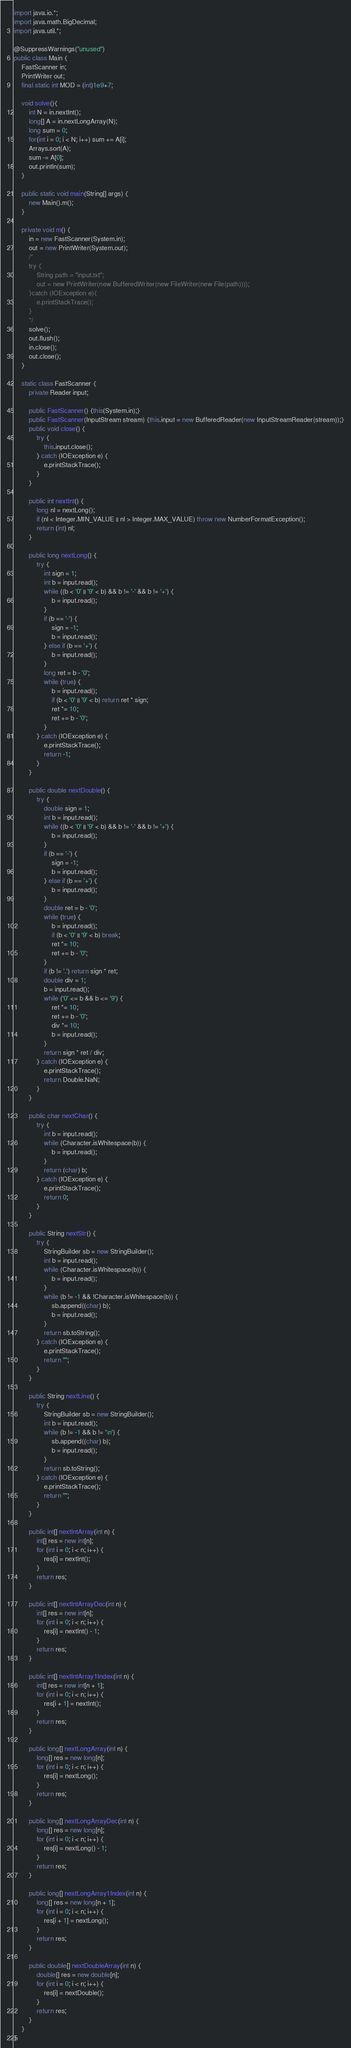<code> <loc_0><loc_0><loc_500><loc_500><_Java_>import java.io.*;
import java.math.BigDecimal;
import java.util.*;

@SuppressWarnings("unused")
public class Main {
    FastScanner in;
    PrintWriter out;
    final static int MOD = (int)1e9+7;
    
    void solve(){
        int N = in.nextInt();
        long[] A = in.nextLongArray(N);
        long sum = 0;
        for(int i = 0; i < N; i++) sum += A[i];
        Arrays.sort(A);
        sum -= A[0];
        out.println(sum);
    }
    
    public static void main(String[] args) {
        new Main().m();
    }
    
    private void m() {
        in = new FastScanner(System.in);
        out = new PrintWriter(System.out);
        /*
        try {
            String path = "input.txt";
            out = new PrintWriter(new BufferedWriter(new FileWriter(new File(path))));
        }catch (IOException e){
            e.printStackTrace();
        }
        */
        solve();
        out.flush();
        in.close();
        out.close();
    }
    
    static class FastScanner {
        private Reader input;
        
        public FastScanner() {this(System.in);}
        public FastScanner(InputStream stream) {this.input = new BufferedReader(new InputStreamReader(stream));}
        public void close() {
            try {
                this.input.close();
            } catch (IOException e) {
                e.printStackTrace();
            }
        }
        
        public int nextInt() {
            long nl = nextLong();
            if (nl < Integer.MIN_VALUE || nl > Integer.MAX_VALUE) throw new NumberFormatException();
            return (int) nl;
        }
        
        public long nextLong() {
            try {
                int sign = 1;
                int b = input.read();
                while ((b < '0' || '9' < b) && b != '-' && b != '+') {
                    b = input.read();
                }
                if (b == '-') {
                    sign = -1;
                    b = input.read();
                } else if (b == '+') {
                    b = input.read();
                }
                long ret = b - '0';
                while (true) {
                    b = input.read();
                    if (b < '0' || '9' < b) return ret * sign;
                    ret *= 10;
                    ret += b - '0';
                }
            } catch (IOException e) {
                e.printStackTrace();
                return -1;
            }
        }
        
        public double nextDouble() {
            try {
                double sign = 1;
                int b = input.read();
                while ((b < '0' || '9' < b) && b != '-' && b != '+') {
                    b = input.read();
                }
                if (b == '-') {
                    sign = -1;
                    b = input.read();
                } else if (b == '+') {
                    b = input.read();
                }
                double ret = b - '0';
                while (true) {
                    b = input.read();
                    if (b < '0' || '9' < b) break;
                    ret *= 10;
                    ret += b - '0';
                }
                if (b != '.') return sign * ret;
                double div = 1;
                b = input.read();
                while ('0' <= b && b <= '9') {
                    ret *= 10;
                    ret += b - '0';
                    div *= 10;
                    b = input.read();
                }
                return sign * ret / div;
            } catch (IOException e) {
                e.printStackTrace();
                return Double.NaN;
            }
        }
        
        public char nextChar() {
            try {
                int b = input.read();
                while (Character.isWhitespace(b)) {
                    b = input.read();
                }
                return (char) b;
            } catch (IOException e) {
                e.printStackTrace();
                return 0;
            }
        }
        
        public String nextStr() {
            try {
                StringBuilder sb = new StringBuilder();
                int b = input.read();
                while (Character.isWhitespace(b)) {
                    b = input.read();
                }
                while (b != -1 && !Character.isWhitespace(b)) {
                    sb.append((char) b);
                    b = input.read();
                }
                return sb.toString();
            } catch (IOException e) {
                e.printStackTrace();
                return "";
            }
        }
        
        public String nextLine() {
            try {
                StringBuilder sb = new StringBuilder();
                int b = input.read();
                while (b != -1 && b != '\n') {
                    sb.append((char) b);
                    b = input.read();
                }
                return sb.toString();
            } catch (IOException e) {
                e.printStackTrace();
                return "";
            }
        }
        
        public int[] nextIntArray(int n) {
            int[] res = new int[n];
            for (int i = 0; i < n; i++) {
                res[i] = nextInt();
            }
            return res;
        }
        
        public int[] nextIntArrayDec(int n) {
            int[] res = new int[n];
            for (int i = 0; i < n; i++) {
                res[i] = nextInt() - 1;
            }
            return res;
        }
        
        public int[] nextIntArray1Index(int n) {
            int[] res = new int[n + 1];
            for (int i = 0; i < n; i++) {
                res[i + 1] = nextInt();
            }
            return res;
        }
        
        public long[] nextLongArray(int n) {
            long[] res = new long[n];
            for (int i = 0; i < n; i++) {
                res[i] = nextLong();
            }
            return res;
        }
        
        public long[] nextLongArrayDec(int n) {
            long[] res = new long[n];
            for (int i = 0; i < n; i++) {
                res[i] = nextLong() - 1;
            }
            return res;
        }
        
        public long[] nextLongArray1Index(int n) {
            long[] res = new long[n + 1];
            for (int i = 0; i < n; i++) {
                res[i + 1] = nextLong();
            }
            return res;
        }
        
        public double[] nextDoubleArray(int n) {
            double[] res = new double[n];
            for (int i = 0; i < n; i++) {
                res[i] = nextDouble();
            }
            return res;
        }
    }
}</code> 